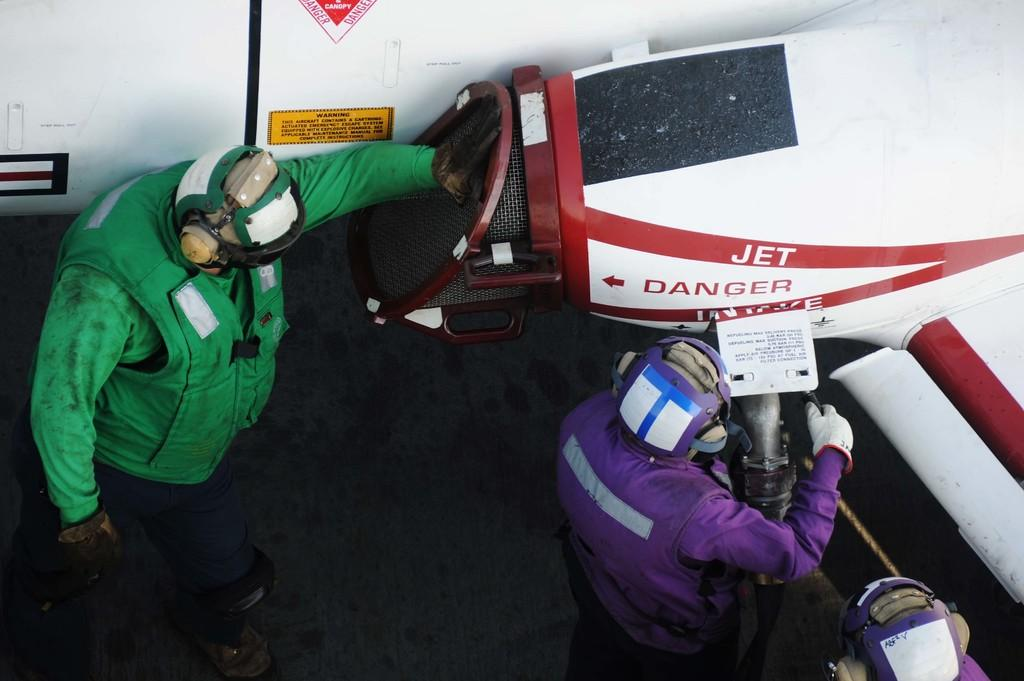How many people are the persons are in the image? There are three persons in the image. What are the persons wearing on their heads? The persons are wearing helmets. What is the main object in the image besides the persons? There is a jet in the image. Can you describe any text on the jet? Yes, the jet has text on it. What is the surface that can be seen in the image? There is a visible surface in the image. What type of brush is being used by the persons in the image? There is no brush visible in the image; the persons are wearing helmets and there is a jet present. Are there any slaves depicted in the image? No, there are no slaves depicted in the image; it features three persons wearing helmets and a jet. 